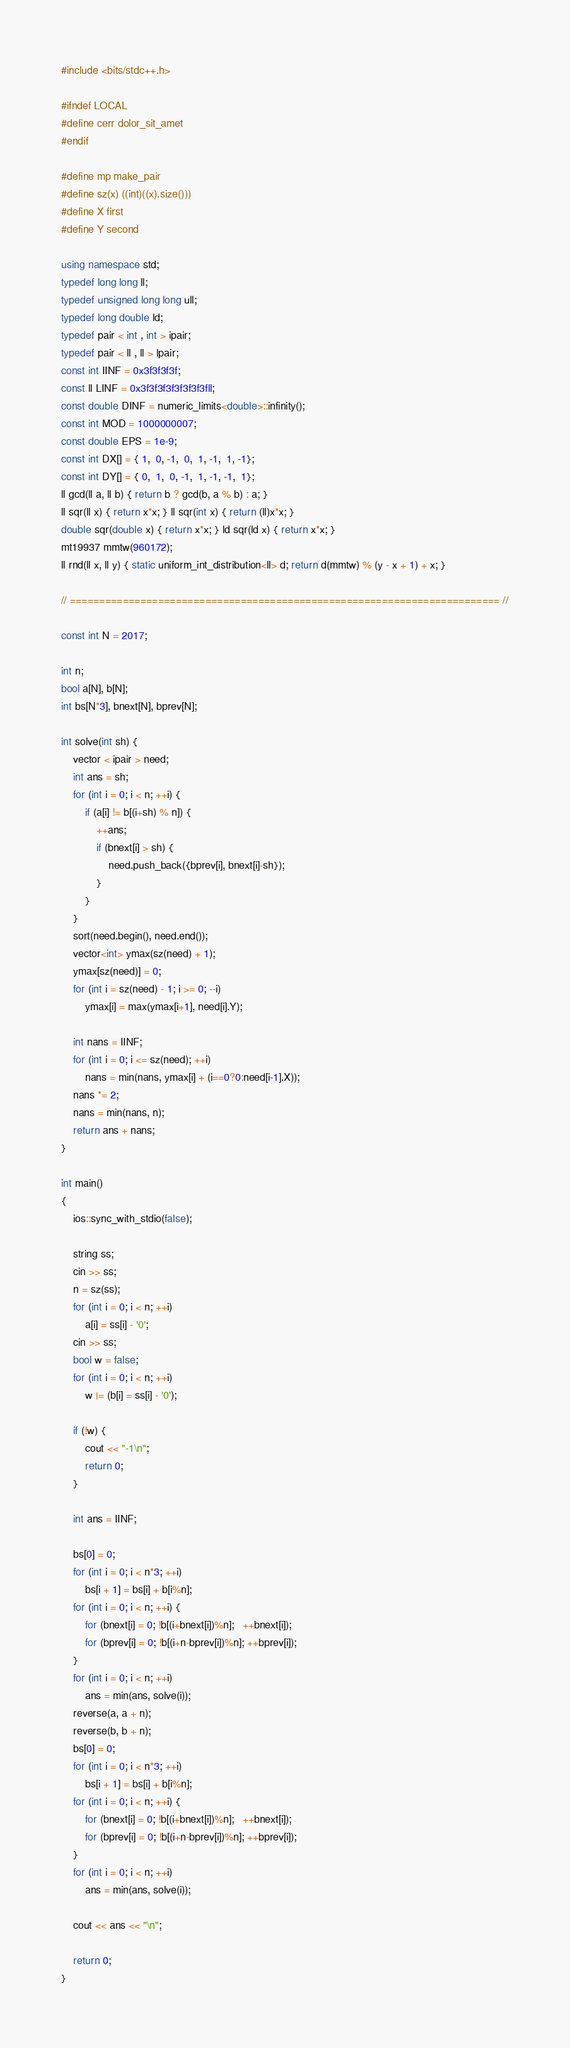<code> <loc_0><loc_0><loc_500><loc_500><_C++_>#include <bits/stdc++.h>

#ifndef LOCAL
#define cerr dolor_sit_amet
#endif

#define mp make_pair
#define sz(x) ((int)((x).size()))
#define X first
#define Y second

using namespace std;
typedef long long ll;
typedef unsigned long long ull;
typedef long double ld;
typedef pair < int , int > ipair;
typedef pair < ll , ll > lpair;
const int IINF = 0x3f3f3f3f;
const ll LINF = 0x3f3f3f3f3f3f3f3fll;
const double DINF = numeric_limits<double>::infinity();
const int MOD = 1000000007;
const double EPS = 1e-9;
const int DX[] = { 1,  0, -1,  0,  1, -1,  1, -1};
const int DY[] = { 0,  1,  0, -1,  1, -1, -1,  1};
ll gcd(ll a, ll b) { return b ? gcd(b, a % b) : a; }
ll sqr(ll x) { return x*x; } ll sqr(int x) { return (ll)x*x; }
double sqr(double x) { return x*x; } ld sqr(ld x) { return x*x; }
mt19937 mmtw(960172);
ll rnd(ll x, ll y) { static uniform_int_distribution<ll> d; return d(mmtw) % (y - x + 1) + x; }

// ========================================================================= //

const int N = 2017;

int n;
bool a[N], b[N];
int bs[N*3], bnext[N], bprev[N];

int solve(int sh) {
    vector < ipair > need;
    int ans = sh;
    for (int i = 0; i < n; ++i) {
        if (a[i] != b[(i+sh) % n]) {
            ++ans;
            if (bnext[i] > sh) {
                need.push_back({bprev[i], bnext[i]-sh});
            }
        }
    }
    sort(need.begin(), need.end());
    vector<int> ymax(sz(need) + 1);
    ymax[sz(need)] = 0;
    for (int i = sz(need) - 1; i >= 0; --i)
        ymax[i] = max(ymax[i+1], need[i].Y);

    int nans = IINF;
    for (int i = 0; i <= sz(need); ++i)
        nans = min(nans, ymax[i] + (i==0?0:need[i-1].X));
    nans *= 2;
    nans = min(nans, n);
    return ans + nans;
}

int main()
{
    ios::sync_with_stdio(false);

    string ss;
    cin >> ss;
    n = sz(ss);
    for (int i = 0; i < n; ++i)
        a[i] = ss[i] - '0';
    cin >> ss;
    bool w = false;
    for (int i = 0; i < n; ++i)
        w |= (b[i] = ss[i] - '0');

    if (!w) {
        cout << "-1\n";
        return 0;
    }

    int ans = IINF;

    bs[0] = 0;
    for (int i = 0; i < n*3; ++i)
        bs[i + 1] = bs[i] + b[i%n];
    for (int i = 0; i < n; ++i) {
        for (bnext[i] = 0; !b[(i+bnext[i])%n];   ++bnext[i]);
        for (bprev[i] = 0; !b[(i+n-bprev[i])%n]; ++bprev[i]);
    }
    for (int i = 0; i < n; ++i)
        ans = min(ans, solve(i));
    reverse(a, a + n);
    reverse(b, b + n);
    bs[0] = 0;
    for (int i = 0; i < n*3; ++i)
        bs[i + 1] = bs[i] + b[i%n];
    for (int i = 0; i < n; ++i) {
        for (bnext[i] = 0; !b[(i+bnext[i])%n];   ++bnext[i]);
        for (bprev[i] = 0; !b[(i+n-bprev[i])%n]; ++bprev[i]);
    }
    for (int i = 0; i < n; ++i)
        ans = min(ans, solve(i));

    cout << ans << "\n";

    return 0;
}
</code> 